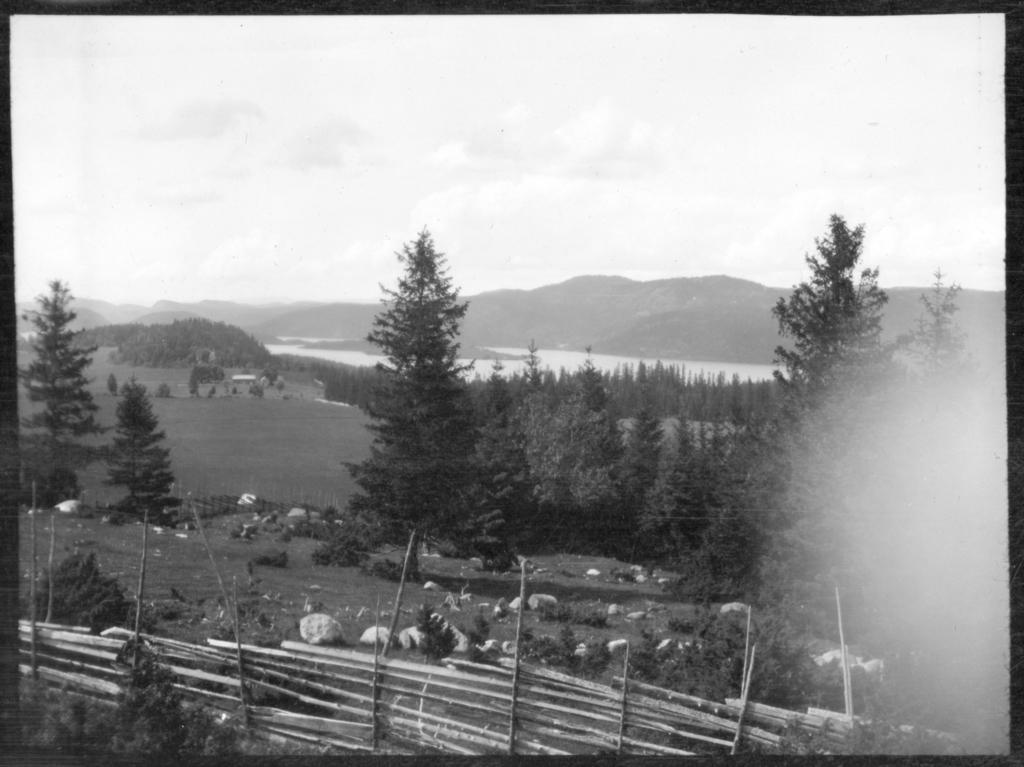What is the color scheme of the image? The image is black and white. What type of fencing can be seen in the image? There is wooden fencing in the image. What type of vegetation is present in the image? Trees are present in the image. What is the ground covered with in the image? The land is covered with grass. What type of geographical feature is visible in the image? There are mountains visible in the image. What body of water is present in the image? There is a pond in the image. What is the condition of the sky in the image? The sky is full of clouds. Can you see any trains passing through the cemetery in the image? There is no cemetery or trains present in the image. Is there a kite flying in the sky in the image? There is no kite visible in the image; the sky is full of clouds. 